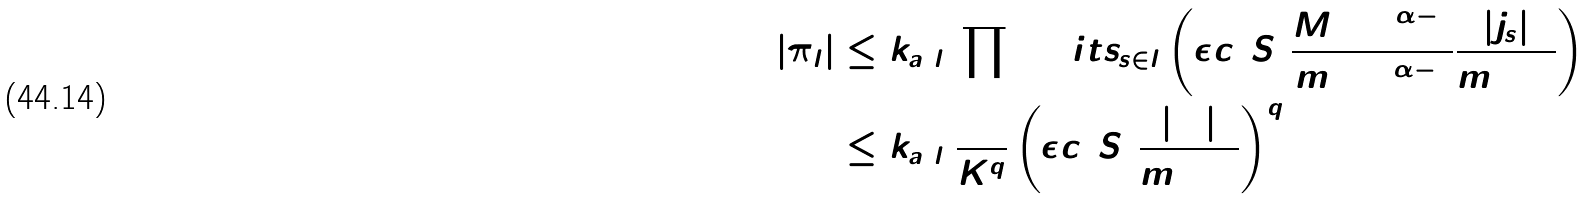<formula> <loc_0><loc_0><loc_500><loc_500>| \pi _ { l } | & \leq k _ { a ( l ) } \prod \lim i t s _ { s \in l } \left ( \epsilon c ( S ) \frac { M ( \Delta ) ^ { \alpha - 1 } } { m ( \Delta ) ^ { \alpha - 1 } } \frac { | j _ { s } | } { m ( \Delta ) } \right ) \\ & \leq k _ { a ( l ) } \frac { 1 } { K ^ { q } } \left ( \epsilon c ( S ) \frac { | \Delta | } { m ( \Delta ) } \right ) ^ { q }</formula> 